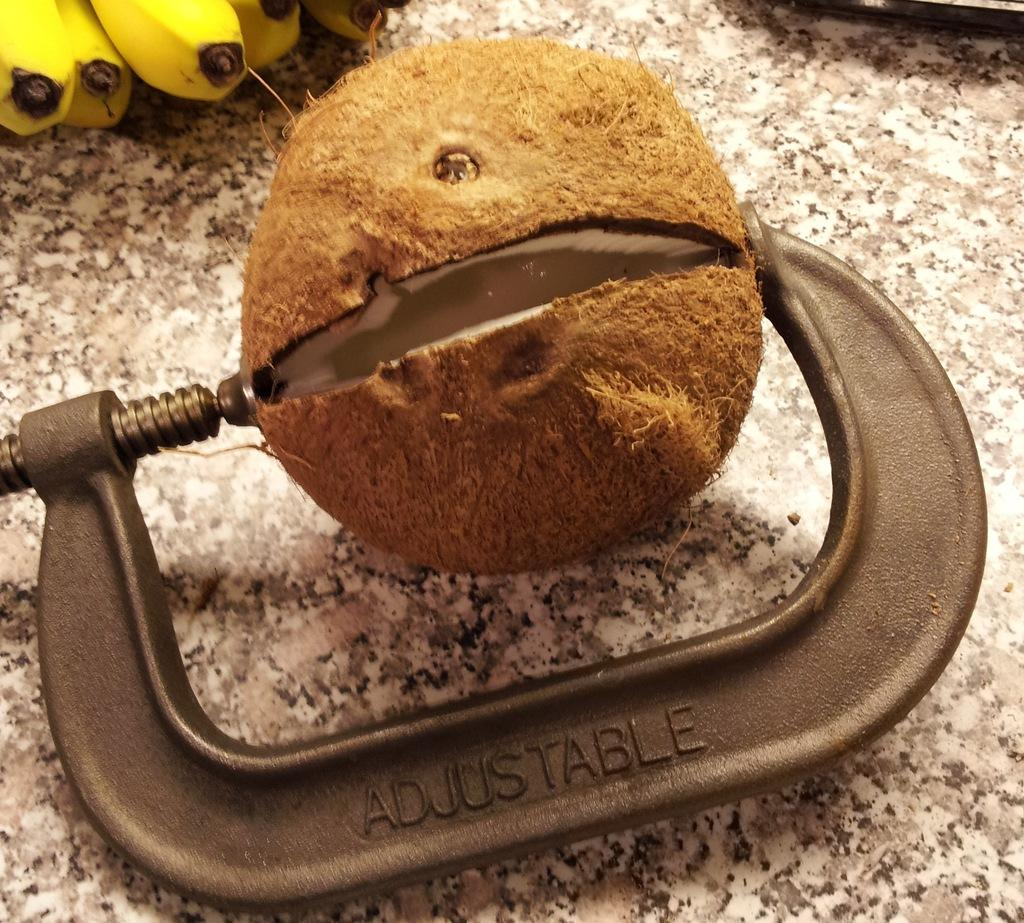What is the main object in the image? There is a coconut in the image. What tool is near the coconut? There is a tool near the coconut. What type of fruit is visible in the top left corner of the image? There is a bunch of bananas in the top left corner of the image. What color are the bananas? The bananas are yellow in color. What material does the surface of the image appear to be on? The image appears to be on a marble stone. What type of art is being created with the coconut and tool in the image? There is no indication of any art being created in the image; it simply shows a coconut and a tool. 